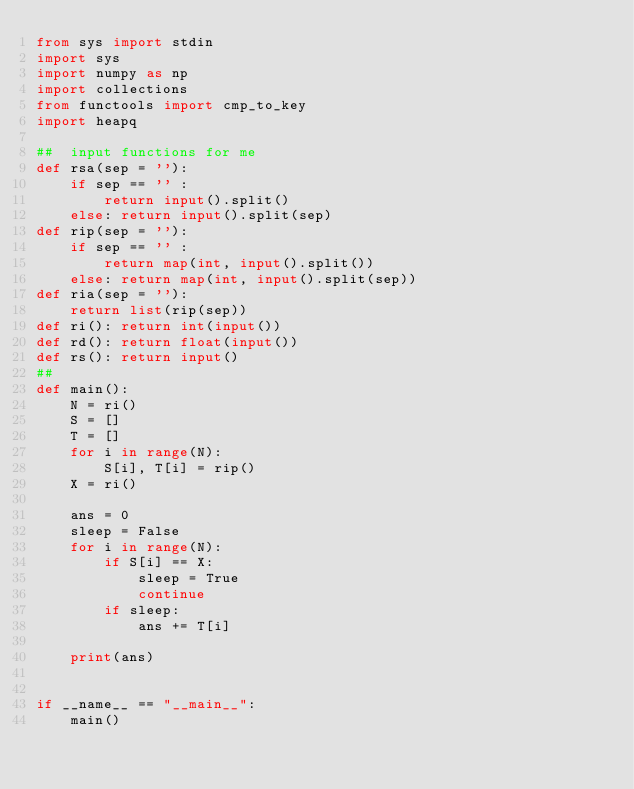<code> <loc_0><loc_0><loc_500><loc_500><_Python_>from sys import stdin
import sys
import numpy as np
import collections
from functools import cmp_to_key
import heapq

##  input functions for me
def rsa(sep = ''):
    if sep == '' :
        return input().split() 
    else: return input().split(sep)
def rip(sep = ''):
    if sep == '' :
        return map(int, input().split()) 
    else: return map(int, input().split(sep))
def ria(sep = ''): 
    return list(rip(sep))
def ri(): return int(input())
def rd(): return float(input())
def rs(): return input()
##
def main():
    N = ri()
    S = []
    T = []
    for i in range(N):
        S[i], T[i] = rip()
    X = ri()

    ans = 0
    sleep = False
    for i in range(N):
        if S[i] == X:
            sleep = True
            continue
        if sleep:
            ans += T[i]
    
    print(ans)


if __name__ == "__main__":
    main()
</code> 